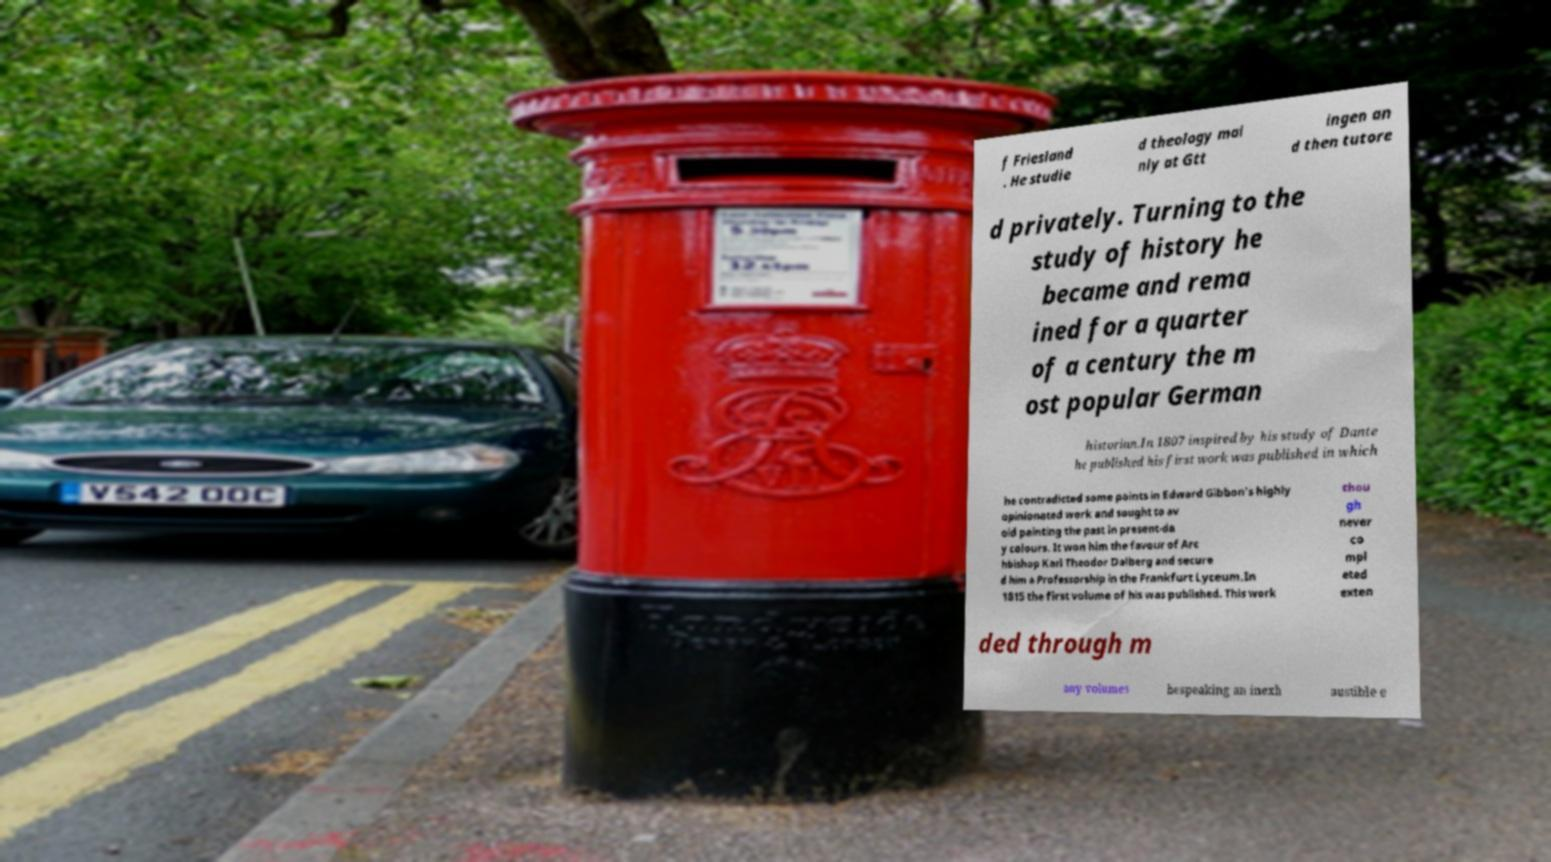There's text embedded in this image that I need extracted. Can you transcribe it verbatim? f Friesland . He studie d theology mai nly at Gtt ingen an d then tutore d privately. Turning to the study of history he became and rema ined for a quarter of a century the m ost popular German historian.In 1807 inspired by his study of Dante he published his first work was published in which he contradicted some points in Edward Gibbon's highly opinionated work and sought to av oid painting the past in present-da y colours. It won him the favour of Arc hbishop Karl Theodor Dalberg and secure d him a Professorship in the Frankfurt Lyceum.In 1815 the first volume of his was published. This work thou gh never co mpl eted exten ded through m any volumes bespeaking an inexh austible e 